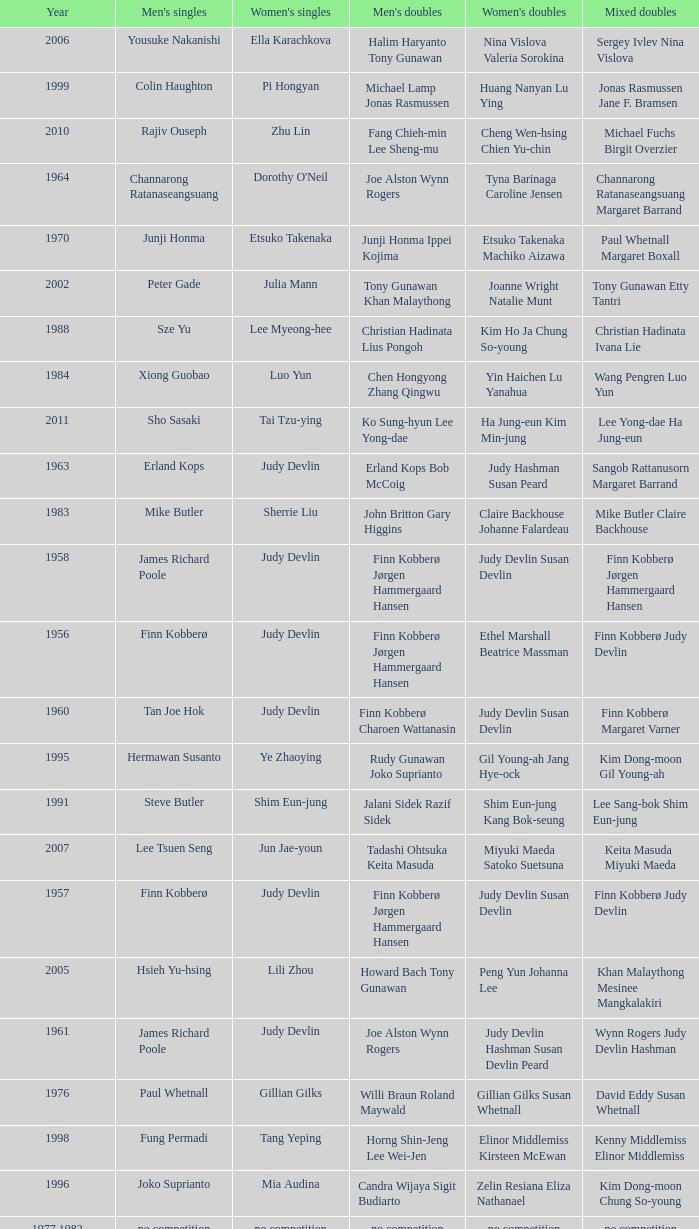Who were the men's doubles champions when the men's singles champion was muljadi? Ng Boon Bee Punch Gunalan. 